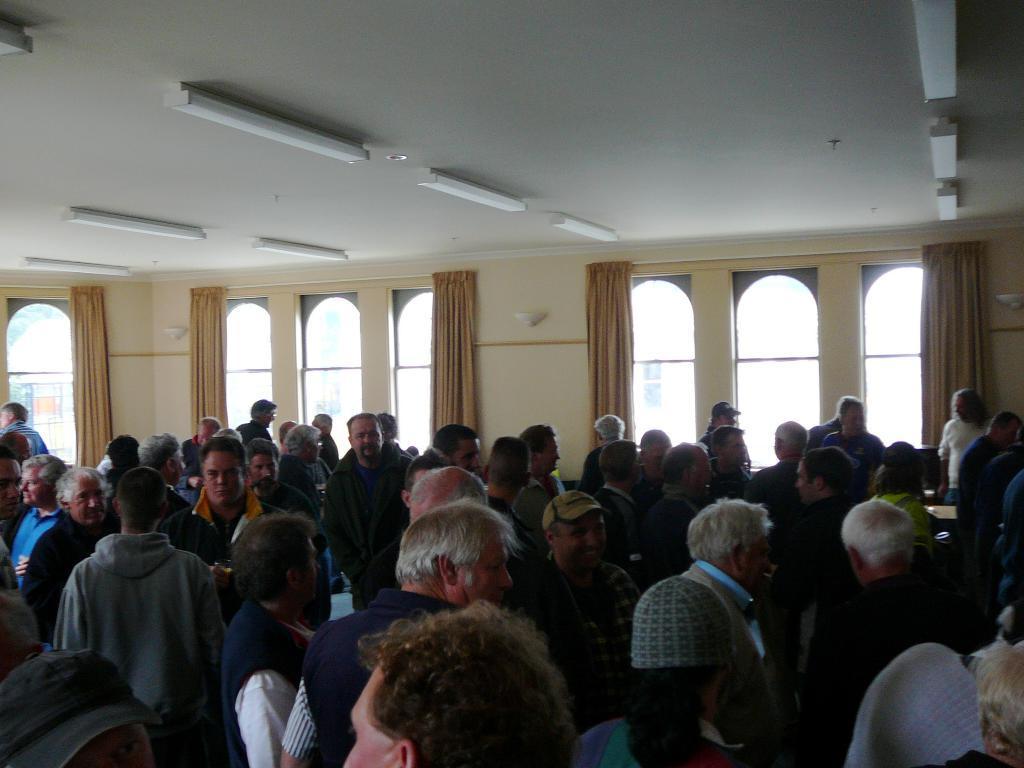Could you give a brief overview of what you see in this image? In this image, we can see a crowd inside the building. There are some windows in the middle of the image contains curtains. There are lights on the ceiling which is at top of the image. 